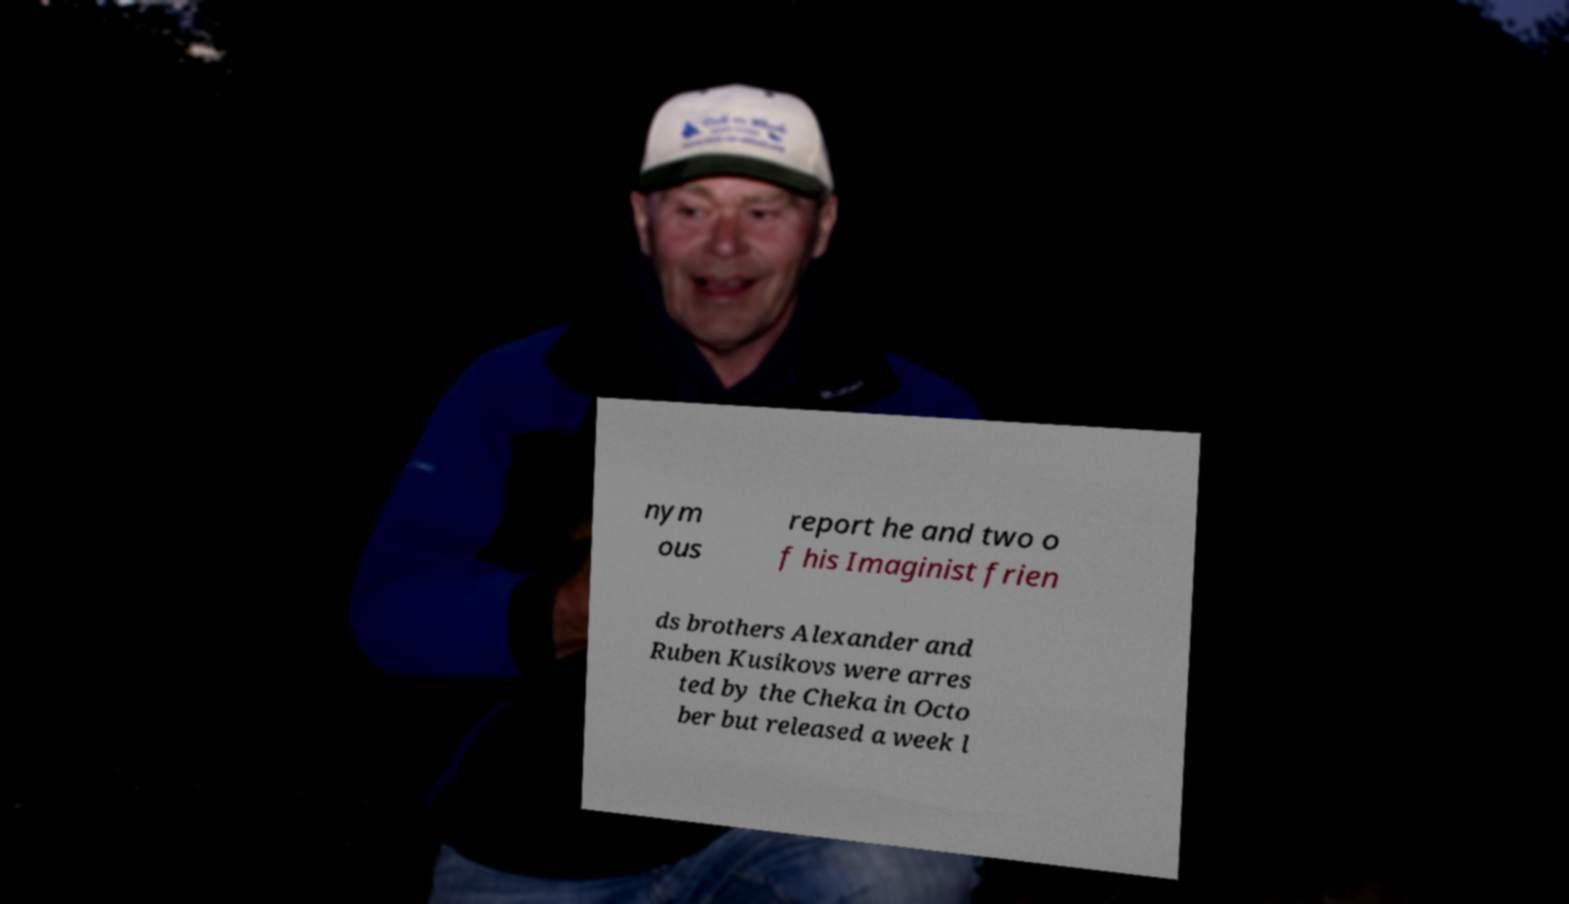There's text embedded in this image that I need extracted. Can you transcribe it verbatim? nym ous report he and two o f his Imaginist frien ds brothers Alexander and Ruben Kusikovs were arres ted by the Cheka in Octo ber but released a week l 